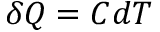Convert formula to latex. <formula><loc_0><loc_0><loc_500><loc_500>\delta Q = C d T</formula> 